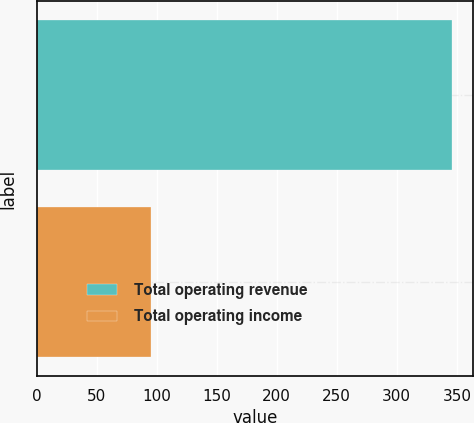Convert chart to OTSL. <chart><loc_0><loc_0><loc_500><loc_500><bar_chart><fcel>Total operating revenue<fcel>Total operating income<nl><fcel>346.1<fcel>95.2<nl></chart> 